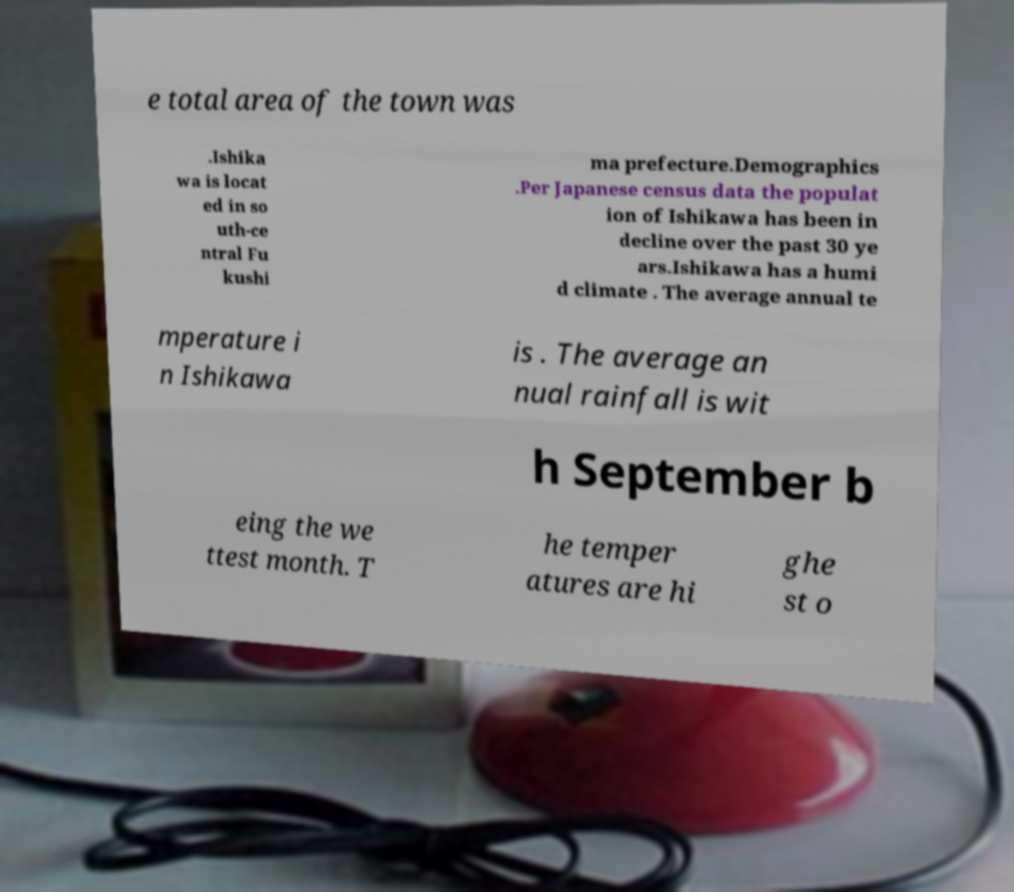Could you assist in decoding the text presented in this image and type it out clearly? e total area of the town was .Ishika wa is locat ed in so uth-ce ntral Fu kushi ma prefecture.Demographics .Per Japanese census data the populat ion of Ishikawa has been in decline over the past 30 ye ars.Ishikawa has a humi d climate . The average annual te mperature i n Ishikawa is . The average an nual rainfall is wit h September b eing the we ttest month. T he temper atures are hi ghe st o 